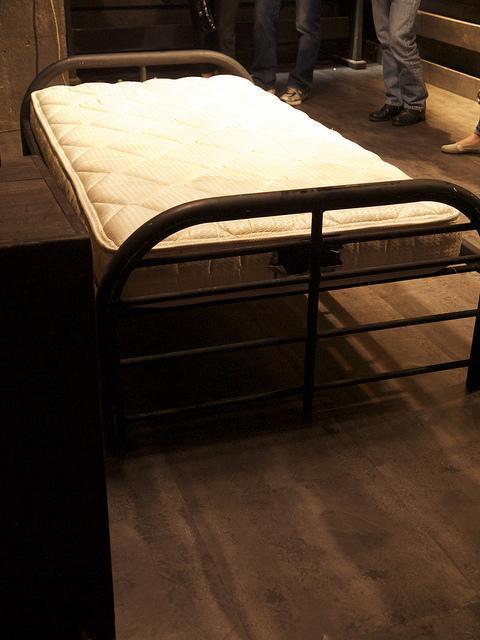How many people can be seen?
Give a very brief answer. 2. How many cars are in the road?
Give a very brief answer. 0. 